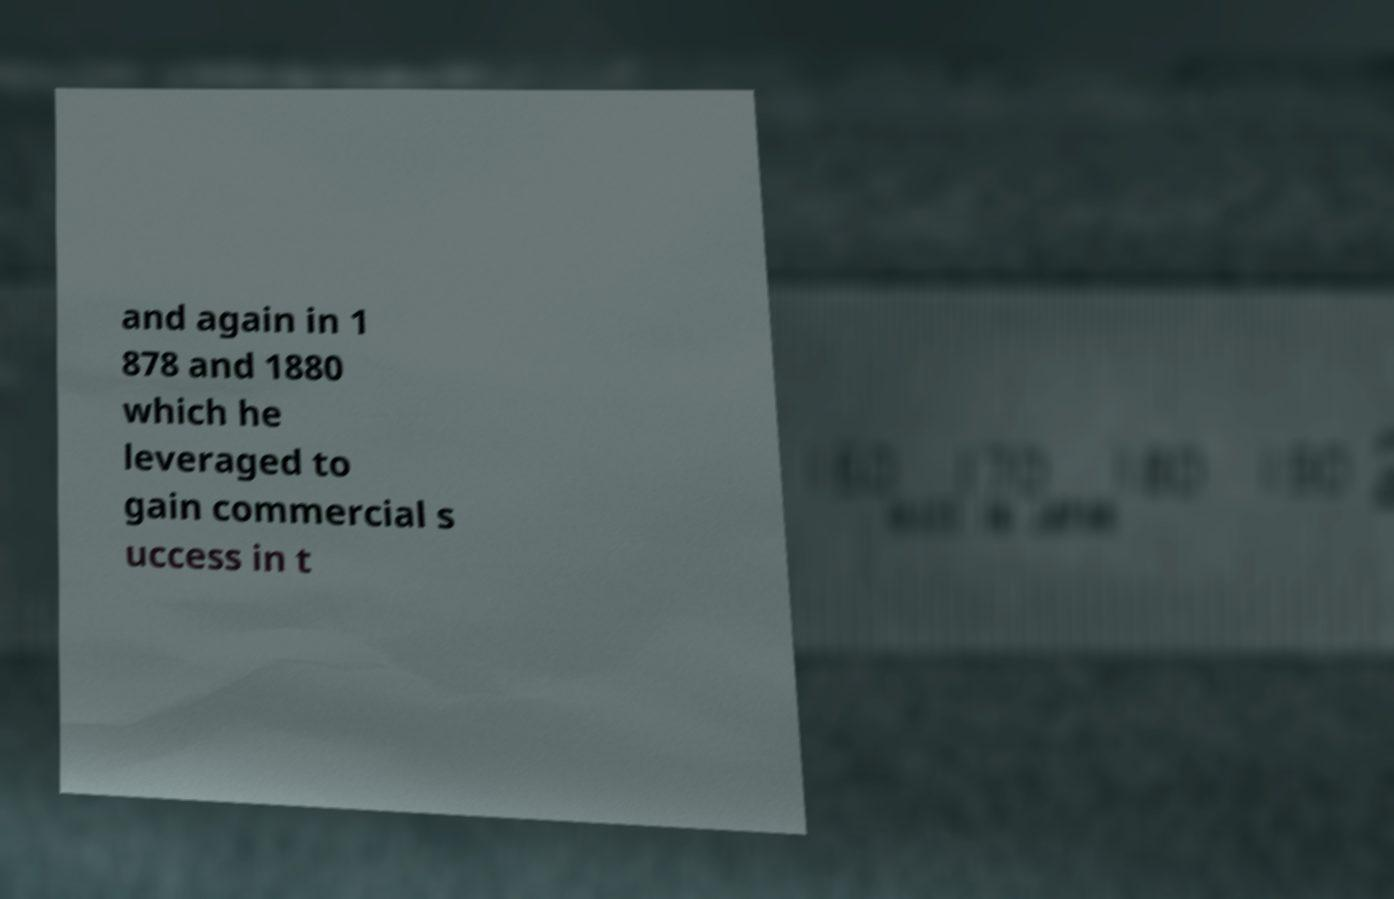I need the written content from this picture converted into text. Can you do that? and again in 1 878 and 1880 which he leveraged to gain commercial s uccess in t 